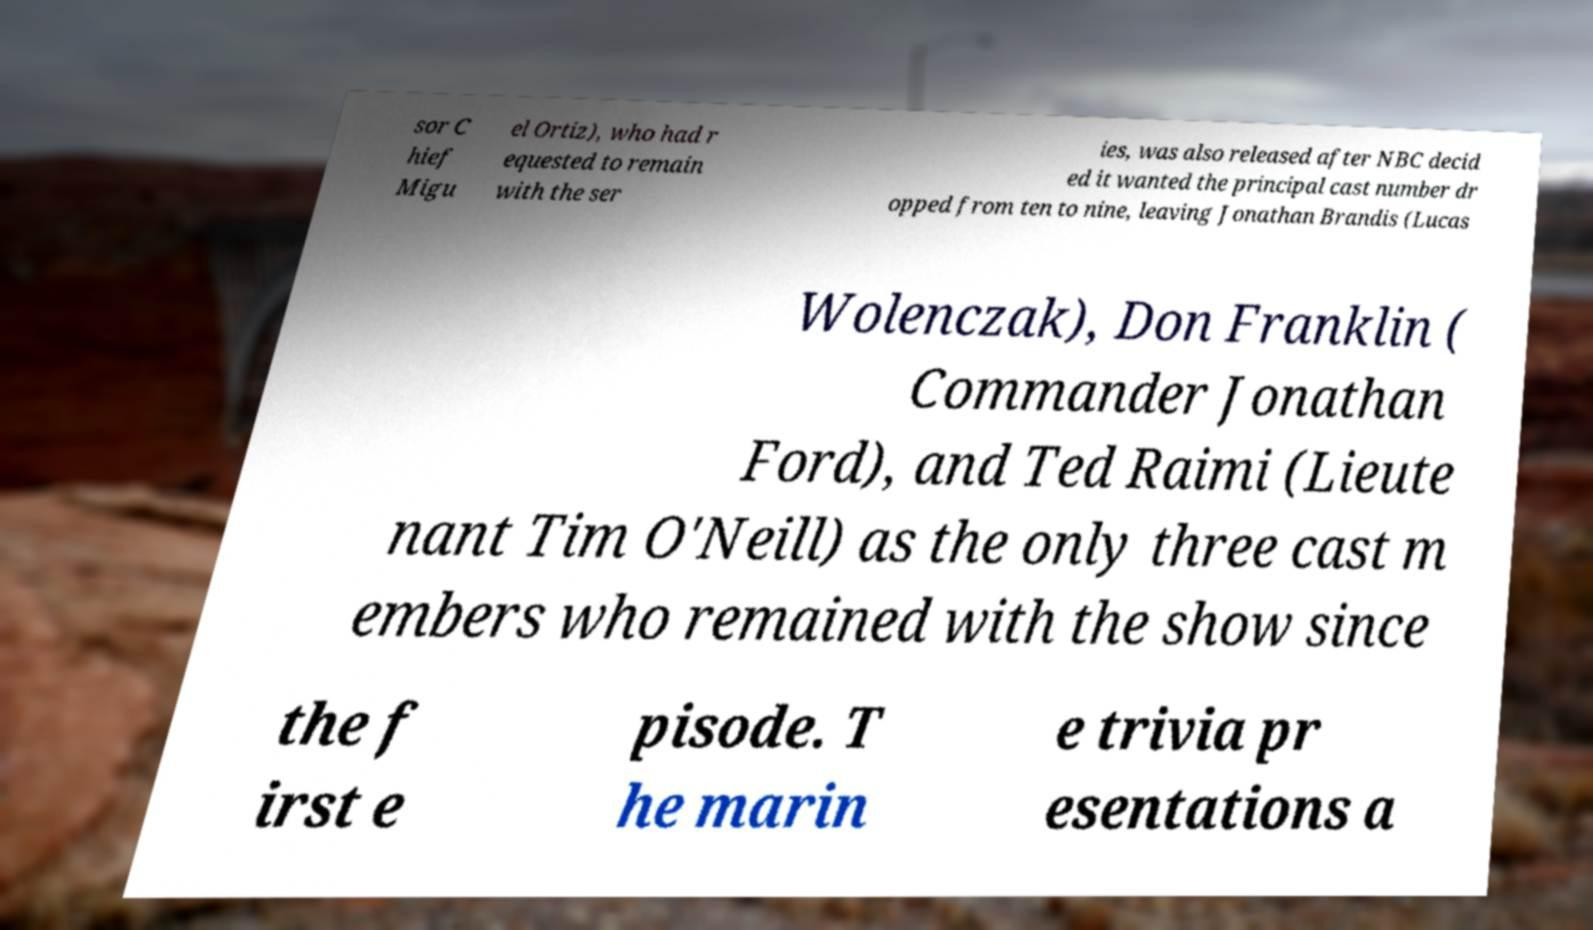Can you read and provide the text displayed in the image?This photo seems to have some interesting text. Can you extract and type it out for me? sor C hief Migu el Ortiz), who had r equested to remain with the ser ies, was also released after NBC decid ed it wanted the principal cast number dr opped from ten to nine, leaving Jonathan Brandis (Lucas Wolenczak), Don Franklin ( Commander Jonathan Ford), and Ted Raimi (Lieute nant Tim O'Neill) as the only three cast m embers who remained with the show since the f irst e pisode. T he marin e trivia pr esentations a 